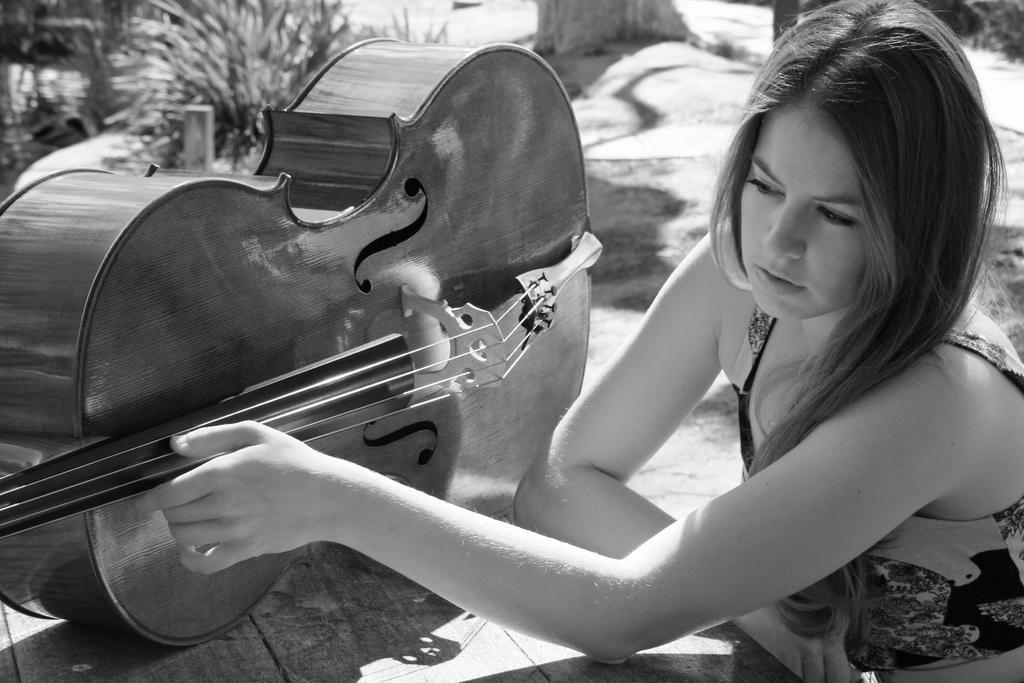In one or two sentences, can you explain what this image depicts? There is a lady and she is touching a guitar. And there is a table and on this table guitar is placed. 